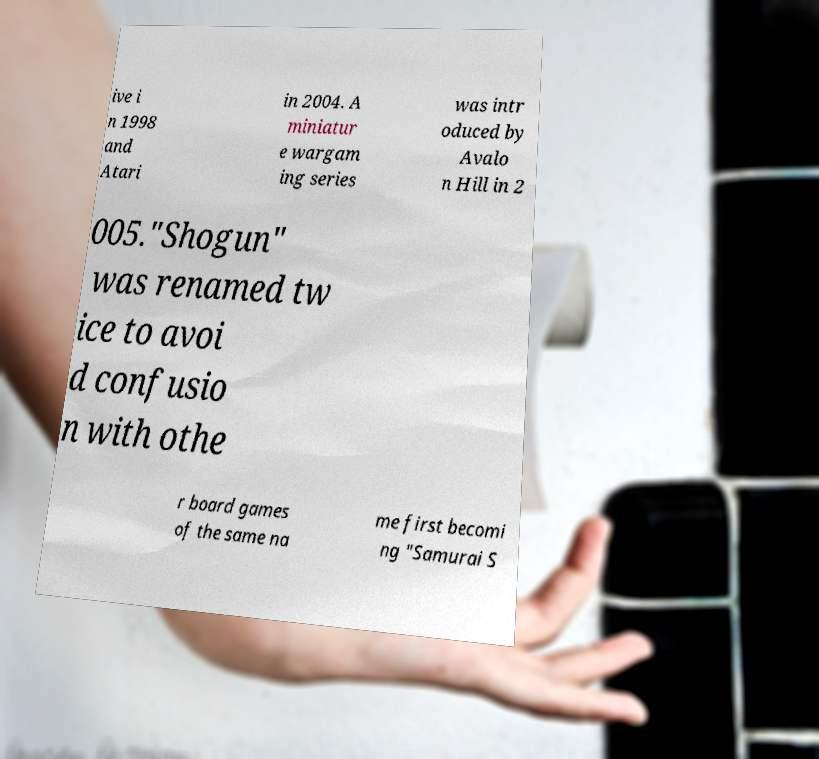Please identify and transcribe the text found in this image. ive i n 1998 and Atari in 2004. A miniatur e wargam ing series was intr oduced by Avalo n Hill in 2 005."Shogun" was renamed tw ice to avoi d confusio n with othe r board games of the same na me first becomi ng "Samurai S 